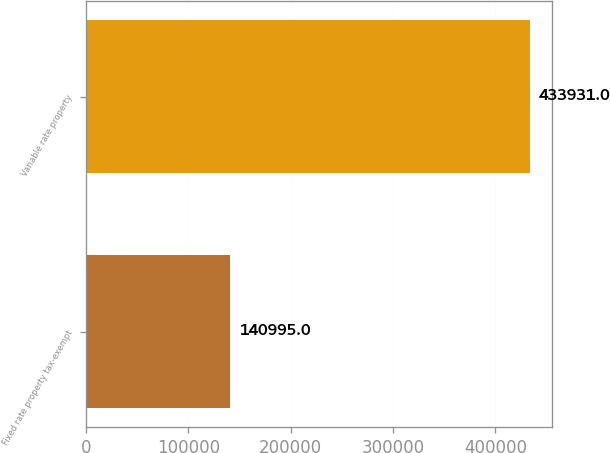Convert chart. <chart><loc_0><loc_0><loc_500><loc_500><bar_chart><fcel>Fixed rate property tax-exempt<fcel>Variable rate property<nl><fcel>140995<fcel>433931<nl></chart> 